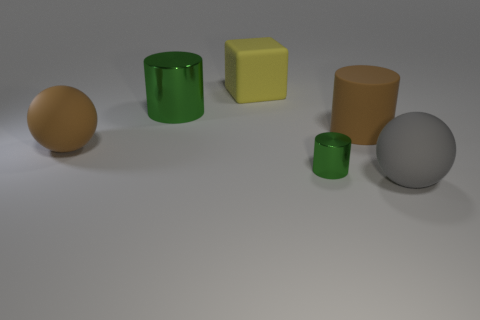Add 2 large green cubes. How many objects exist? 8 Subtract all cubes. How many objects are left? 5 Subtract 0 yellow cylinders. How many objects are left? 6 Subtract all cylinders. Subtract all large cylinders. How many objects are left? 1 Add 4 large green objects. How many large green objects are left? 5 Add 4 big green matte blocks. How many big green matte blocks exist? 4 